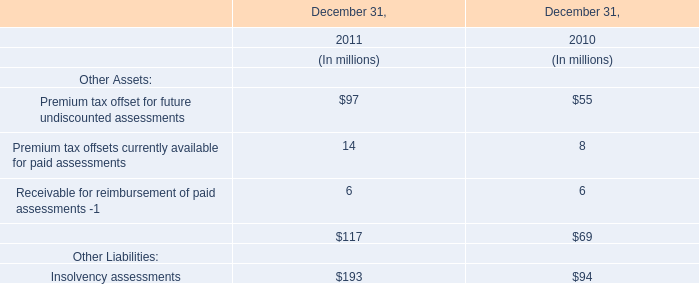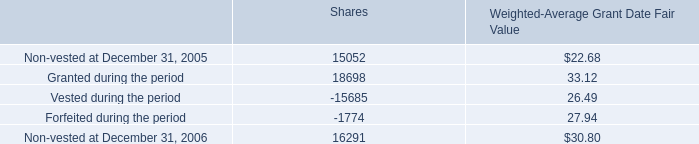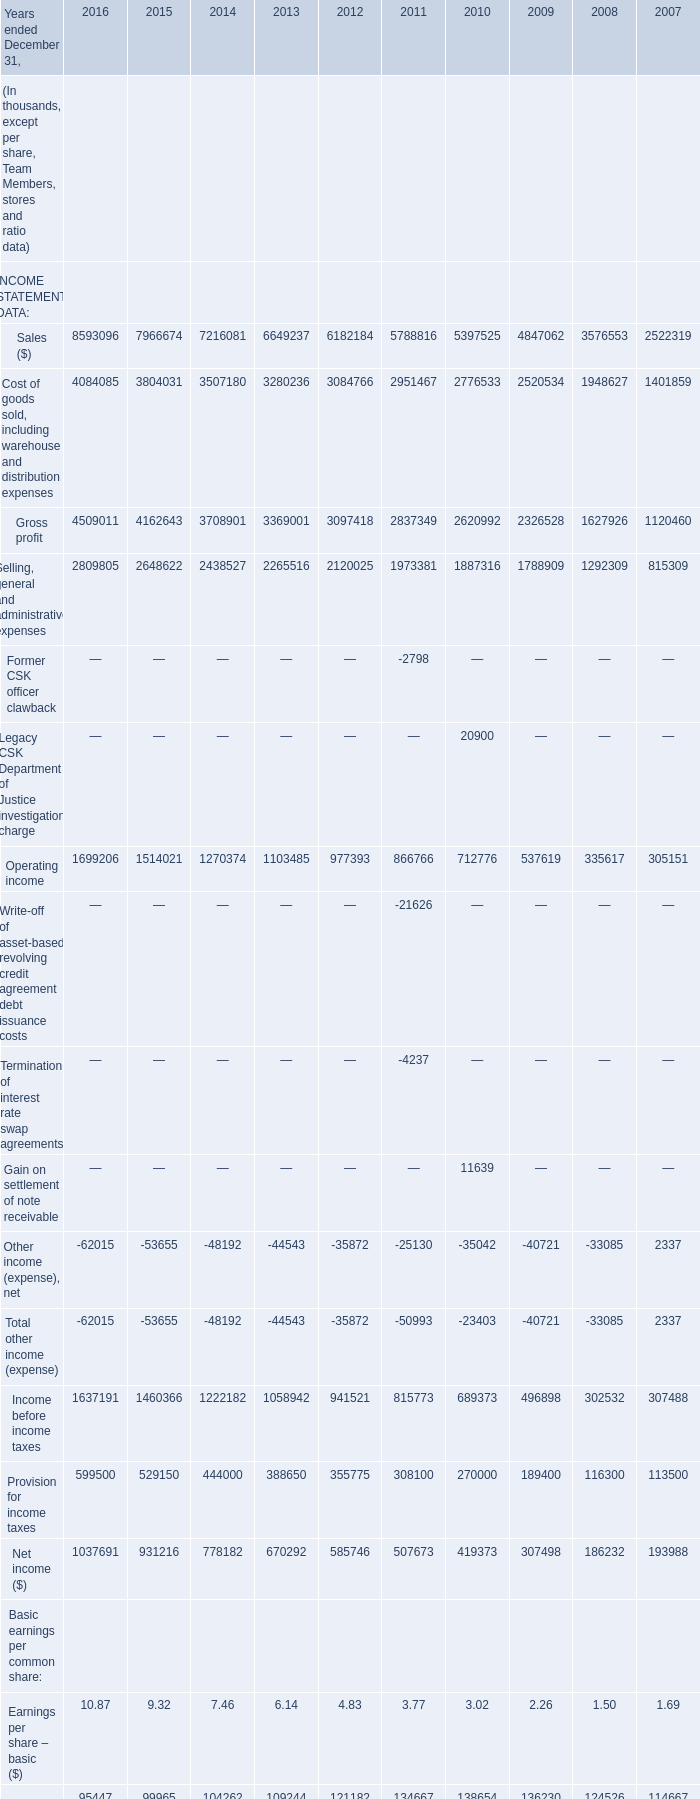what is the amount of cash raised from the issuance of shares during 2015 , in millions? 
Computations: ((161903 * 27.57) / 1000000)
Answer: 4.46367. 